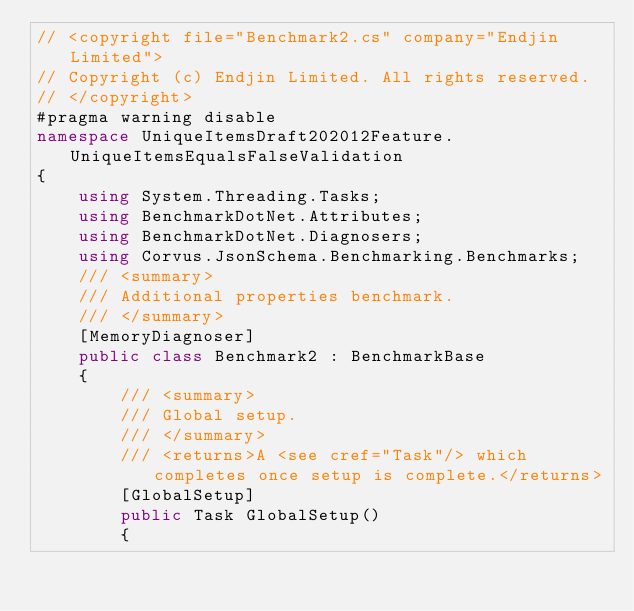<code> <loc_0><loc_0><loc_500><loc_500><_C#_>// <copyright file="Benchmark2.cs" company="Endjin Limited">
// Copyright (c) Endjin Limited. All rights reserved.
// </copyright>
#pragma warning disable
namespace UniqueItemsDraft202012Feature.UniqueItemsEqualsFalseValidation
{
    using System.Threading.Tasks;
    using BenchmarkDotNet.Attributes;
    using BenchmarkDotNet.Diagnosers;
    using Corvus.JsonSchema.Benchmarking.Benchmarks;
    /// <summary>
    /// Additional properties benchmark.
    /// </summary>
    [MemoryDiagnoser]
    public class Benchmark2 : BenchmarkBase
    {
        /// <summary>
        /// Global setup.
        /// </summary>
        /// <returns>A <see cref="Task"/> which completes once setup is complete.</returns>
        [GlobalSetup]
        public Task GlobalSetup()
        {</code> 